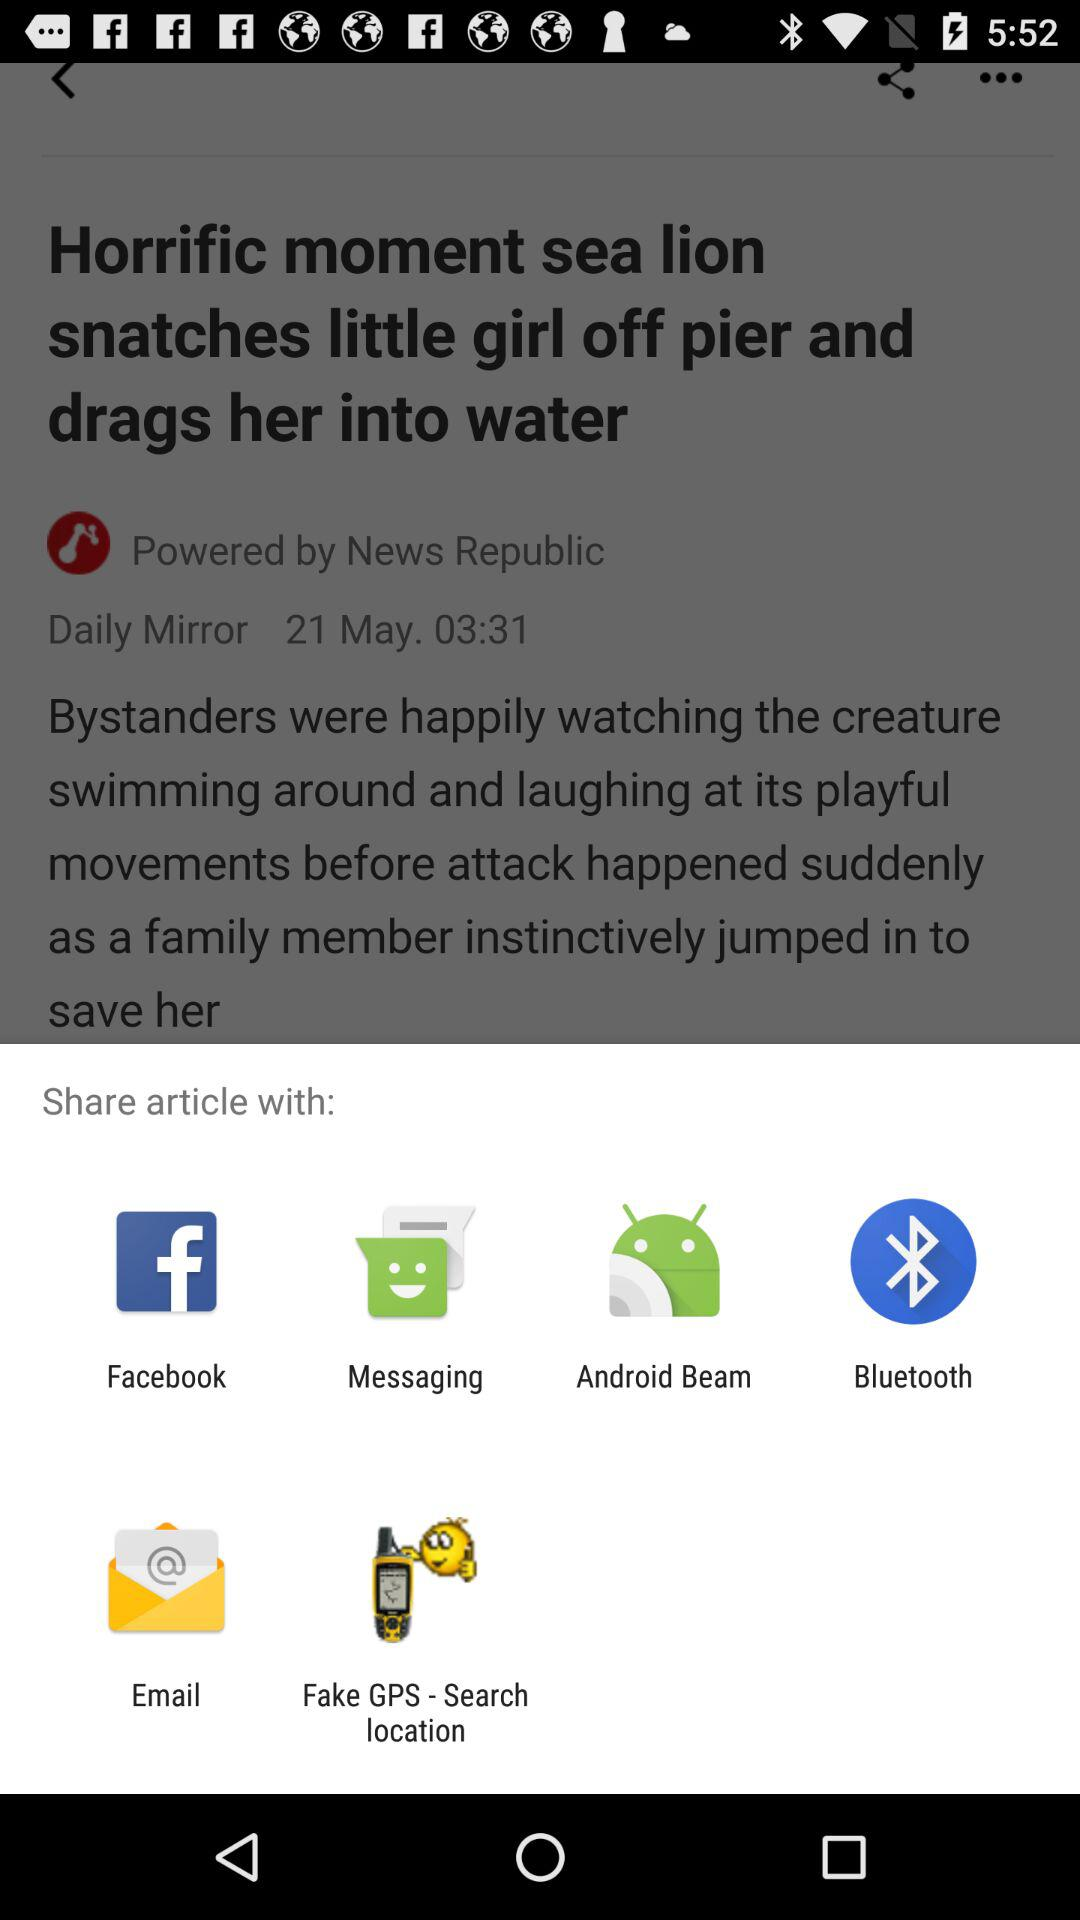Through which app can we share? You can share through "Facebook", "Messaging", "Android Beam", "Bluetooth", "Email" and "Fake GPS - Search location". 